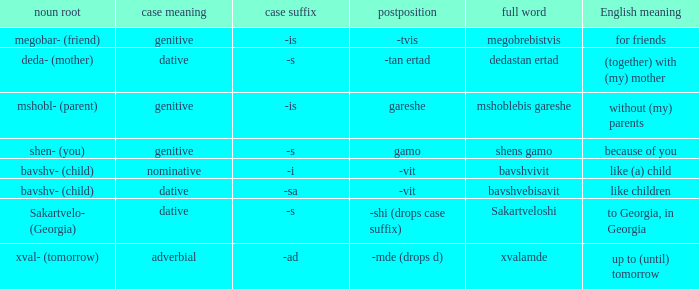What is the Full Word, when Case Suffix (case) is "-sa (dative)"? Bavshvebisavit. 